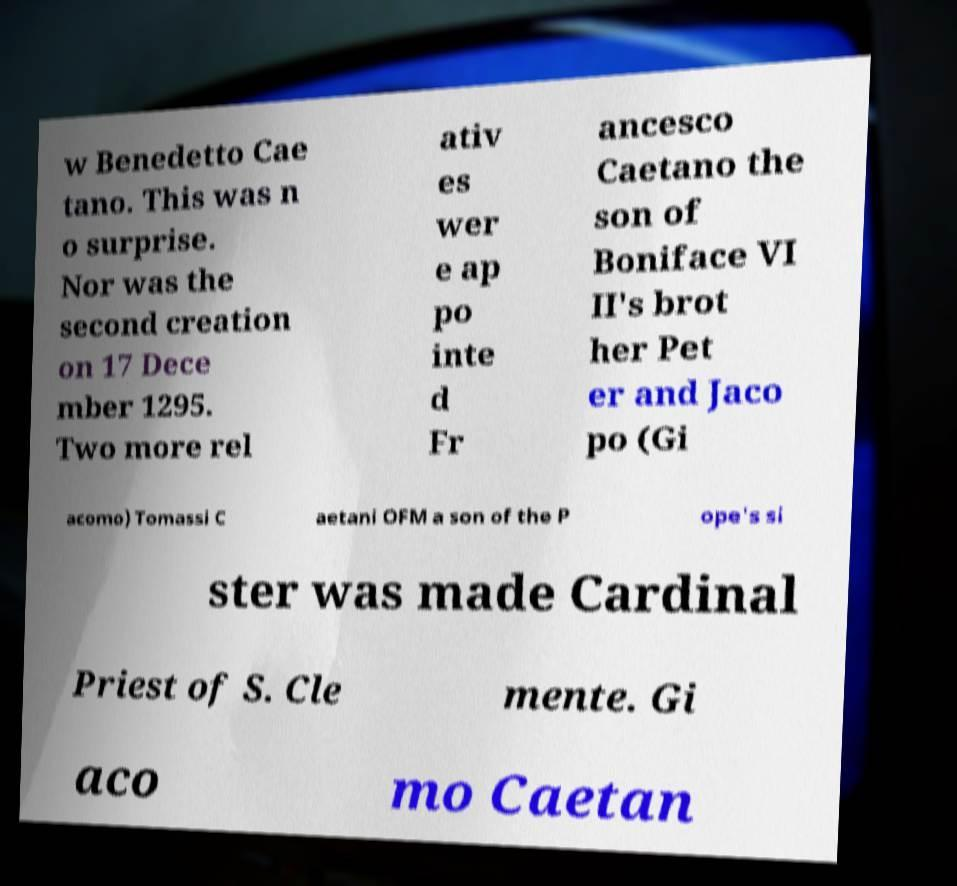What messages or text are displayed in this image? I need them in a readable, typed format. w Benedetto Cae tano. This was n o surprise. Nor was the second creation on 17 Dece mber 1295. Two more rel ativ es wer e ap po inte d Fr ancesco Caetano the son of Boniface VI II's brot her Pet er and Jaco po (Gi acomo) Tomassi C aetani OFM a son of the P ope's si ster was made Cardinal Priest of S. Cle mente. Gi aco mo Caetan 